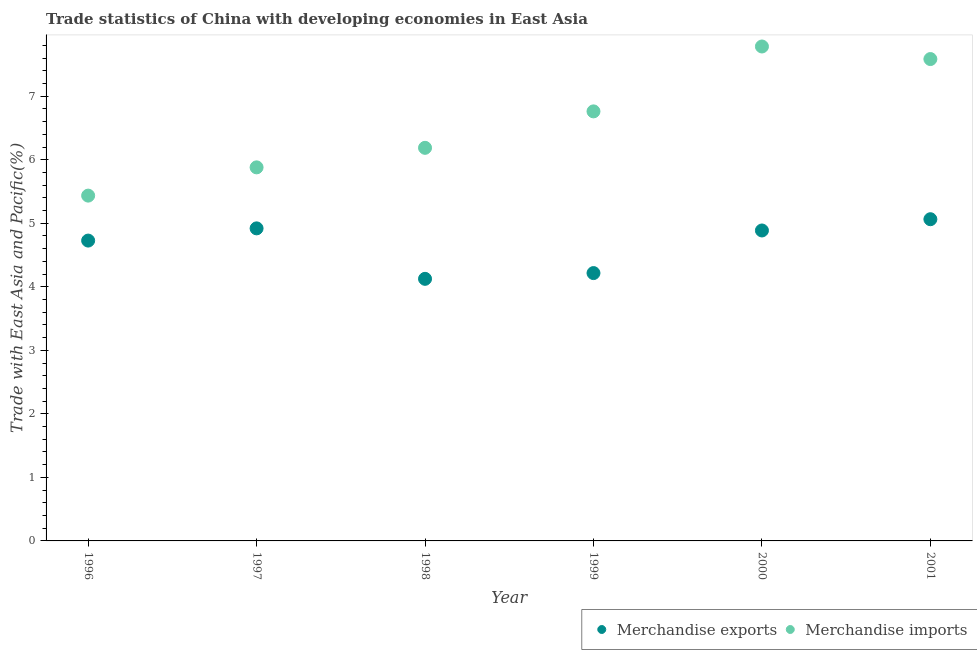How many different coloured dotlines are there?
Offer a very short reply. 2. What is the merchandise exports in 1999?
Keep it short and to the point. 4.22. Across all years, what is the maximum merchandise exports?
Provide a short and direct response. 5.06. Across all years, what is the minimum merchandise imports?
Make the answer very short. 5.43. What is the total merchandise exports in the graph?
Ensure brevity in your answer.  27.94. What is the difference between the merchandise imports in 1996 and that in 1998?
Your answer should be compact. -0.75. What is the difference between the merchandise imports in 1997 and the merchandise exports in 1998?
Give a very brief answer. 1.75. What is the average merchandise imports per year?
Make the answer very short. 6.6. In the year 1998, what is the difference between the merchandise imports and merchandise exports?
Give a very brief answer. 2.06. In how many years, is the merchandise exports greater than 3.6 %?
Make the answer very short. 6. What is the ratio of the merchandise imports in 1999 to that in 2000?
Give a very brief answer. 0.87. What is the difference between the highest and the second highest merchandise exports?
Provide a short and direct response. 0.14. What is the difference between the highest and the lowest merchandise exports?
Make the answer very short. 0.94. Is the merchandise exports strictly greater than the merchandise imports over the years?
Provide a succinct answer. No. Is the merchandise imports strictly less than the merchandise exports over the years?
Offer a terse response. No. How many years are there in the graph?
Your answer should be compact. 6. What is the difference between two consecutive major ticks on the Y-axis?
Your answer should be compact. 1. Are the values on the major ticks of Y-axis written in scientific E-notation?
Provide a short and direct response. No. Does the graph contain any zero values?
Keep it short and to the point. No. How many legend labels are there?
Offer a very short reply. 2. How are the legend labels stacked?
Offer a very short reply. Horizontal. What is the title of the graph?
Provide a short and direct response. Trade statistics of China with developing economies in East Asia. Does "Attending school" appear as one of the legend labels in the graph?
Keep it short and to the point. No. What is the label or title of the Y-axis?
Offer a terse response. Trade with East Asia and Pacific(%). What is the Trade with East Asia and Pacific(%) of Merchandise exports in 1996?
Give a very brief answer. 4.73. What is the Trade with East Asia and Pacific(%) of Merchandise imports in 1996?
Provide a succinct answer. 5.43. What is the Trade with East Asia and Pacific(%) in Merchandise exports in 1997?
Keep it short and to the point. 4.92. What is the Trade with East Asia and Pacific(%) in Merchandise imports in 1997?
Offer a terse response. 5.88. What is the Trade with East Asia and Pacific(%) in Merchandise exports in 1998?
Ensure brevity in your answer.  4.13. What is the Trade with East Asia and Pacific(%) in Merchandise imports in 1998?
Give a very brief answer. 6.19. What is the Trade with East Asia and Pacific(%) in Merchandise exports in 1999?
Provide a succinct answer. 4.22. What is the Trade with East Asia and Pacific(%) in Merchandise imports in 1999?
Offer a terse response. 6.76. What is the Trade with East Asia and Pacific(%) in Merchandise exports in 2000?
Your answer should be very brief. 4.89. What is the Trade with East Asia and Pacific(%) in Merchandise imports in 2000?
Your answer should be very brief. 7.78. What is the Trade with East Asia and Pacific(%) of Merchandise exports in 2001?
Make the answer very short. 5.06. What is the Trade with East Asia and Pacific(%) in Merchandise imports in 2001?
Keep it short and to the point. 7.58. Across all years, what is the maximum Trade with East Asia and Pacific(%) in Merchandise exports?
Your answer should be very brief. 5.06. Across all years, what is the maximum Trade with East Asia and Pacific(%) of Merchandise imports?
Your answer should be compact. 7.78. Across all years, what is the minimum Trade with East Asia and Pacific(%) in Merchandise exports?
Your response must be concise. 4.13. Across all years, what is the minimum Trade with East Asia and Pacific(%) of Merchandise imports?
Offer a terse response. 5.43. What is the total Trade with East Asia and Pacific(%) in Merchandise exports in the graph?
Offer a very short reply. 27.94. What is the total Trade with East Asia and Pacific(%) in Merchandise imports in the graph?
Your answer should be very brief. 39.63. What is the difference between the Trade with East Asia and Pacific(%) in Merchandise exports in 1996 and that in 1997?
Provide a succinct answer. -0.19. What is the difference between the Trade with East Asia and Pacific(%) in Merchandise imports in 1996 and that in 1997?
Ensure brevity in your answer.  -0.44. What is the difference between the Trade with East Asia and Pacific(%) in Merchandise exports in 1996 and that in 1998?
Your answer should be compact. 0.6. What is the difference between the Trade with East Asia and Pacific(%) of Merchandise imports in 1996 and that in 1998?
Make the answer very short. -0.75. What is the difference between the Trade with East Asia and Pacific(%) in Merchandise exports in 1996 and that in 1999?
Make the answer very short. 0.51. What is the difference between the Trade with East Asia and Pacific(%) in Merchandise imports in 1996 and that in 1999?
Offer a terse response. -1.33. What is the difference between the Trade with East Asia and Pacific(%) of Merchandise exports in 1996 and that in 2000?
Your answer should be compact. -0.16. What is the difference between the Trade with East Asia and Pacific(%) of Merchandise imports in 1996 and that in 2000?
Your answer should be compact. -2.35. What is the difference between the Trade with East Asia and Pacific(%) in Merchandise exports in 1996 and that in 2001?
Offer a very short reply. -0.34. What is the difference between the Trade with East Asia and Pacific(%) in Merchandise imports in 1996 and that in 2001?
Keep it short and to the point. -2.15. What is the difference between the Trade with East Asia and Pacific(%) in Merchandise exports in 1997 and that in 1998?
Give a very brief answer. 0.79. What is the difference between the Trade with East Asia and Pacific(%) in Merchandise imports in 1997 and that in 1998?
Make the answer very short. -0.31. What is the difference between the Trade with East Asia and Pacific(%) in Merchandise exports in 1997 and that in 1999?
Give a very brief answer. 0.7. What is the difference between the Trade with East Asia and Pacific(%) of Merchandise imports in 1997 and that in 1999?
Your answer should be very brief. -0.88. What is the difference between the Trade with East Asia and Pacific(%) of Merchandise imports in 1997 and that in 2000?
Offer a terse response. -1.9. What is the difference between the Trade with East Asia and Pacific(%) of Merchandise exports in 1997 and that in 2001?
Provide a succinct answer. -0.14. What is the difference between the Trade with East Asia and Pacific(%) in Merchandise imports in 1997 and that in 2001?
Keep it short and to the point. -1.7. What is the difference between the Trade with East Asia and Pacific(%) in Merchandise exports in 1998 and that in 1999?
Give a very brief answer. -0.09. What is the difference between the Trade with East Asia and Pacific(%) of Merchandise imports in 1998 and that in 1999?
Provide a succinct answer. -0.57. What is the difference between the Trade with East Asia and Pacific(%) of Merchandise exports in 1998 and that in 2000?
Your answer should be very brief. -0.76. What is the difference between the Trade with East Asia and Pacific(%) of Merchandise imports in 1998 and that in 2000?
Offer a very short reply. -1.59. What is the difference between the Trade with East Asia and Pacific(%) of Merchandise exports in 1998 and that in 2001?
Offer a very short reply. -0.94. What is the difference between the Trade with East Asia and Pacific(%) in Merchandise imports in 1998 and that in 2001?
Make the answer very short. -1.4. What is the difference between the Trade with East Asia and Pacific(%) of Merchandise exports in 1999 and that in 2000?
Make the answer very short. -0.67. What is the difference between the Trade with East Asia and Pacific(%) of Merchandise imports in 1999 and that in 2000?
Provide a short and direct response. -1.02. What is the difference between the Trade with East Asia and Pacific(%) of Merchandise exports in 1999 and that in 2001?
Provide a succinct answer. -0.85. What is the difference between the Trade with East Asia and Pacific(%) of Merchandise imports in 1999 and that in 2001?
Offer a terse response. -0.82. What is the difference between the Trade with East Asia and Pacific(%) of Merchandise exports in 2000 and that in 2001?
Offer a terse response. -0.18. What is the difference between the Trade with East Asia and Pacific(%) in Merchandise imports in 2000 and that in 2001?
Make the answer very short. 0.2. What is the difference between the Trade with East Asia and Pacific(%) in Merchandise exports in 1996 and the Trade with East Asia and Pacific(%) in Merchandise imports in 1997?
Your response must be concise. -1.15. What is the difference between the Trade with East Asia and Pacific(%) in Merchandise exports in 1996 and the Trade with East Asia and Pacific(%) in Merchandise imports in 1998?
Your answer should be compact. -1.46. What is the difference between the Trade with East Asia and Pacific(%) in Merchandise exports in 1996 and the Trade with East Asia and Pacific(%) in Merchandise imports in 1999?
Your response must be concise. -2.03. What is the difference between the Trade with East Asia and Pacific(%) of Merchandise exports in 1996 and the Trade with East Asia and Pacific(%) of Merchandise imports in 2000?
Give a very brief answer. -3.05. What is the difference between the Trade with East Asia and Pacific(%) in Merchandise exports in 1996 and the Trade with East Asia and Pacific(%) in Merchandise imports in 2001?
Give a very brief answer. -2.86. What is the difference between the Trade with East Asia and Pacific(%) of Merchandise exports in 1997 and the Trade with East Asia and Pacific(%) of Merchandise imports in 1998?
Keep it short and to the point. -1.27. What is the difference between the Trade with East Asia and Pacific(%) of Merchandise exports in 1997 and the Trade with East Asia and Pacific(%) of Merchandise imports in 1999?
Provide a succinct answer. -1.84. What is the difference between the Trade with East Asia and Pacific(%) of Merchandise exports in 1997 and the Trade with East Asia and Pacific(%) of Merchandise imports in 2000?
Provide a succinct answer. -2.86. What is the difference between the Trade with East Asia and Pacific(%) of Merchandise exports in 1997 and the Trade with East Asia and Pacific(%) of Merchandise imports in 2001?
Provide a succinct answer. -2.66. What is the difference between the Trade with East Asia and Pacific(%) in Merchandise exports in 1998 and the Trade with East Asia and Pacific(%) in Merchandise imports in 1999?
Provide a succinct answer. -2.64. What is the difference between the Trade with East Asia and Pacific(%) of Merchandise exports in 1998 and the Trade with East Asia and Pacific(%) of Merchandise imports in 2000?
Keep it short and to the point. -3.66. What is the difference between the Trade with East Asia and Pacific(%) in Merchandise exports in 1998 and the Trade with East Asia and Pacific(%) in Merchandise imports in 2001?
Make the answer very short. -3.46. What is the difference between the Trade with East Asia and Pacific(%) in Merchandise exports in 1999 and the Trade with East Asia and Pacific(%) in Merchandise imports in 2000?
Your answer should be compact. -3.57. What is the difference between the Trade with East Asia and Pacific(%) of Merchandise exports in 1999 and the Trade with East Asia and Pacific(%) of Merchandise imports in 2001?
Provide a short and direct response. -3.37. What is the difference between the Trade with East Asia and Pacific(%) in Merchandise exports in 2000 and the Trade with East Asia and Pacific(%) in Merchandise imports in 2001?
Provide a short and direct response. -2.7. What is the average Trade with East Asia and Pacific(%) of Merchandise exports per year?
Your response must be concise. 4.66. What is the average Trade with East Asia and Pacific(%) of Merchandise imports per year?
Your answer should be very brief. 6.6. In the year 1996, what is the difference between the Trade with East Asia and Pacific(%) of Merchandise exports and Trade with East Asia and Pacific(%) of Merchandise imports?
Offer a very short reply. -0.71. In the year 1997, what is the difference between the Trade with East Asia and Pacific(%) of Merchandise exports and Trade with East Asia and Pacific(%) of Merchandise imports?
Offer a terse response. -0.96. In the year 1998, what is the difference between the Trade with East Asia and Pacific(%) in Merchandise exports and Trade with East Asia and Pacific(%) in Merchandise imports?
Provide a short and direct response. -2.06. In the year 1999, what is the difference between the Trade with East Asia and Pacific(%) in Merchandise exports and Trade with East Asia and Pacific(%) in Merchandise imports?
Offer a terse response. -2.55. In the year 2000, what is the difference between the Trade with East Asia and Pacific(%) of Merchandise exports and Trade with East Asia and Pacific(%) of Merchandise imports?
Provide a short and direct response. -2.9. In the year 2001, what is the difference between the Trade with East Asia and Pacific(%) of Merchandise exports and Trade with East Asia and Pacific(%) of Merchandise imports?
Keep it short and to the point. -2.52. What is the ratio of the Trade with East Asia and Pacific(%) in Merchandise exports in 1996 to that in 1997?
Your answer should be very brief. 0.96. What is the ratio of the Trade with East Asia and Pacific(%) in Merchandise imports in 1996 to that in 1997?
Provide a short and direct response. 0.92. What is the ratio of the Trade with East Asia and Pacific(%) in Merchandise exports in 1996 to that in 1998?
Provide a succinct answer. 1.15. What is the ratio of the Trade with East Asia and Pacific(%) of Merchandise imports in 1996 to that in 1998?
Make the answer very short. 0.88. What is the ratio of the Trade with East Asia and Pacific(%) of Merchandise exports in 1996 to that in 1999?
Give a very brief answer. 1.12. What is the ratio of the Trade with East Asia and Pacific(%) of Merchandise imports in 1996 to that in 1999?
Keep it short and to the point. 0.8. What is the ratio of the Trade with East Asia and Pacific(%) in Merchandise exports in 1996 to that in 2000?
Ensure brevity in your answer.  0.97. What is the ratio of the Trade with East Asia and Pacific(%) in Merchandise imports in 1996 to that in 2000?
Provide a succinct answer. 0.7. What is the ratio of the Trade with East Asia and Pacific(%) of Merchandise exports in 1996 to that in 2001?
Provide a short and direct response. 0.93. What is the ratio of the Trade with East Asia and Pacific(%) in Merchandise imports in 1996 to that in 2001?
Your response must be concise. 0.72. What is the ratio of the Trade with East Asia and Pacific(%) of Merchandise exports in 1997 to that in 1998?
Offer a very short reply. 1.19. What is the ratio of the Trade with East Asia and Pacific(%) in Merchandise imports in 1997 to that in 1998?
Give a very brief answer. 0.95. What is the ratio of the Trade with East Asia and Pacific(%) of Merchandise exports in 1997 to that in 1999?
Give a very brief answer. 1.17. What is the ratio of the Trade with East Asia and Pacific(%) of Merchandise imports in 1997 to that in 1999?
Offer a terse response. 0.87. What is the ratio of the Trade with East Asia and Pacific(%) in Merchandise exports in 1997 to that in 2000?
Provide a short and direct response. 1.01. What is the ratio of the Trade with East Asia and Pacific(%) in Merchandise imports in 1997 to that in 2000?
Offer a very short reply. 0.76. What is the ratio of the Trade with East Asia and Pacific(%) of Merchandise exports in 1997 to that in 2001?
Your answer should be very brief. 0.97. What is the ratio of the Trade with East Asia and Pacific(%) of Merchandise imports in 1997 to that in 2001?
Your answer should be compact. 0.78. What is the ratio of the Trade with East Asia and Pacific(%) of Merchandise exports in 1998 to that in 1999?
Offer a terse response. 0.98. What is the ratio of the Trade with East Asia and Pacific(%) of Merchandise imports in 1998 to that in 1999?
Keep it short and to the point. 0.92. What is the ratio of the Trade with East Asia and Pacific(%) of Merchandise exports in 1998 to that in 2000?
Your answer should be very brief. 0.84. What is the ratio of the Trade with East Asia and Pacific(%) in Merchandise imports in 1998 to that in 2000?
Provide a succinct answer. 0.8. What is the ratio of the Trade with East Asia and Pacific(%) in Merchandise exports in 1998 to that in 2001?
Give a very brief answer. 0.81. What is the ratio of the Trade with East Asia and Pacific(%) in Merchandise imports in 1998 to that in 2001?
Offer a very short reply. 0.82. What is the ratio of the Trade with East Asia and Pacific(%) of Merchandise exports in 1999 to that in 2000?
Offer a very short reply. 0.86. What is the ratio of the Trade with East Asia and Pacific(%) of Merchandise imports in 1999 to that in 2000?
Provide a short and direct response. 0.87. What is the ratio of the Trade with East Asia and Pacific(%) in Merchandise exports in 1999 to that in 2001?
Your answer should be compact. 0.83. What is the ratio of the Trade with East Asia and Pacific(%) in Merchandise imports in 1999 to that in 2001?
Your answer should be very brief. 0.89. What is the ratio of the Trade with East Asia and Pacific(%) of Merchandise exports in 2000 to that in 2001?
Give a very brief answer. 0.96. What is the ratio of the Trade with East Asia and Pacific(%) of Merchandise imports in 2000 to that in 2001?
Provide a succinct answer. 1.03. What is the difference between the highest and the second highest Trade with East Asia and Pacific(%) in Merchandise exports?
Your response must be concise. 0.14. What is the difference between the highest and the second highest Trade with East Asia and Pacific(%) of Merchandise imports?
Give a very brief answer. 0.2. What is the difference between the highest and the lowest Trade with East Asia and Pacific(%) in Merchandise exports?
Offer a terse response. 0.94. What is the difference between the highest and the lowest Trade with East Asia and Pacific(%) of Merchandise imports?
Keep it short and to the point. 2.35. 